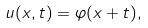<formula> <loc_0><loc_0><loc_500><loc_500>u ( x , t ) = \varphi ( x + t ) ,</formula> 